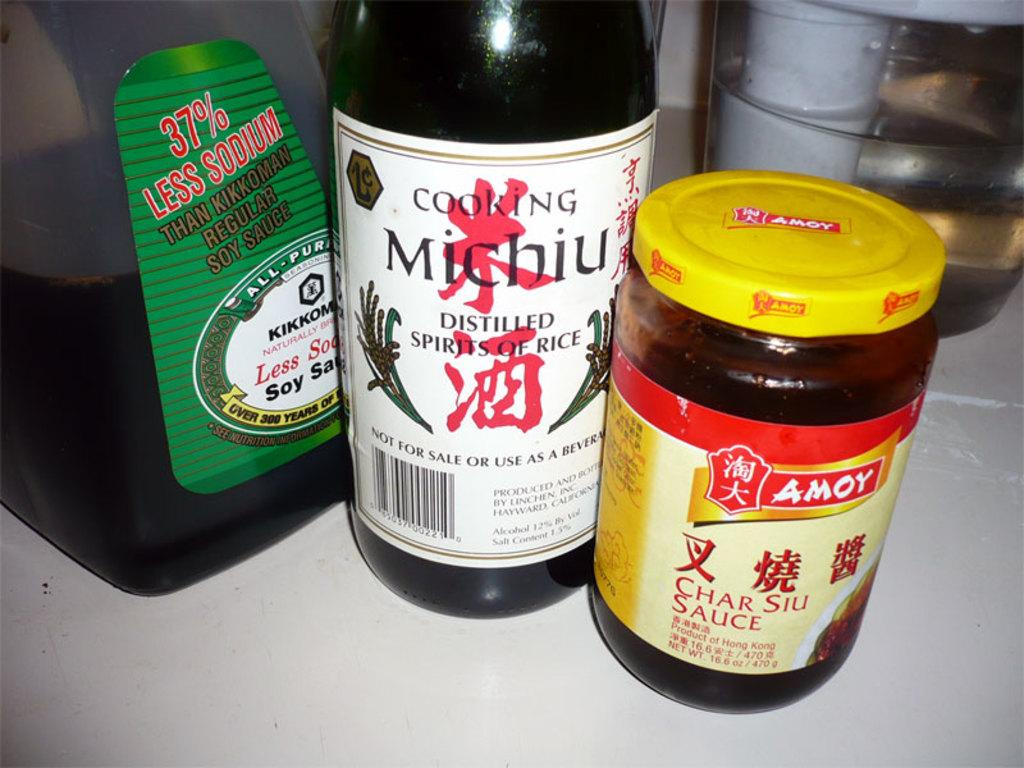<image>
Provide a brief description of the given image. A bottle of cooking Michiu sits with two other bottles. 